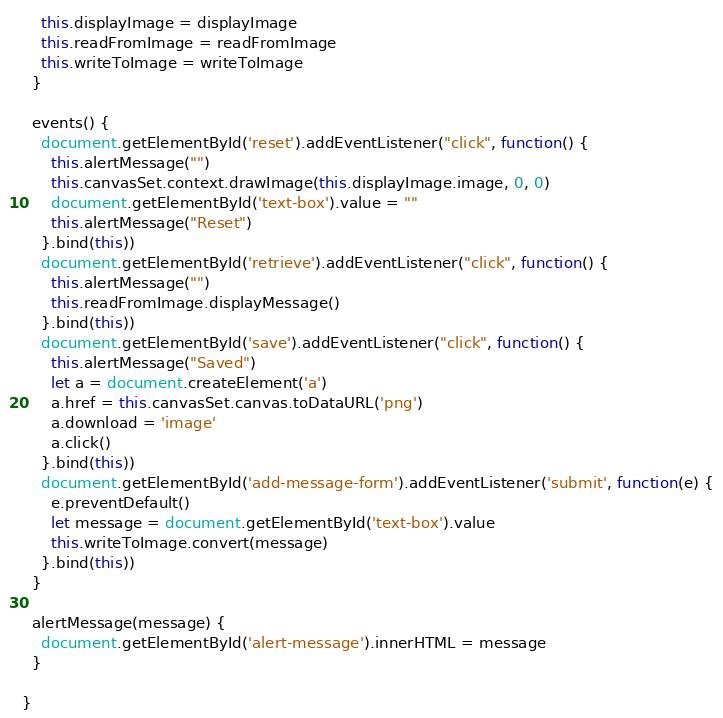<code> <loc_0><loc_0><loc_500><loc_500><_JavaScript_>    this.displayImage = displayImage
    this.readFromImage = readFromImage
    this.writeToImage = writeToImage
  }

  events() {
    document.getElementById('reset').addEventListener("click", function() {
      this.alertMessage("")
      this.canvasSet.context.drawImage(this.displayImage.image, 0, 0)
      document.getElementById('text-box').value = ""
      this.alertMessage("Reset")
    }.bind(this))
    document.getElementById('retrieve').addEventListener("click", function() {
      this.alertMessage("")
      this.readFromImage.displayMessage()
    }.bind(this))
    document.getElementById('save').addEventListener("click", function() {
      this.alertMessage("Saved")
      let a = document.createElement('a')
      a.href = this.canvasSet.canvas.toDataURL('png')
      a.download = 'image'
      a.click()
    }.bind(this))
    document.getElementById('add-message-form').addEventListener('submit', function(e) {
      e.preventDefault()
      let message = document.getElementById('text-box').value
      this.writeToImage.convert(message)
    }.bind(this))
  }

  alertMessage(message) {
    document.getElementById('alert-message').innerHTML = message
  }

}
</code> 